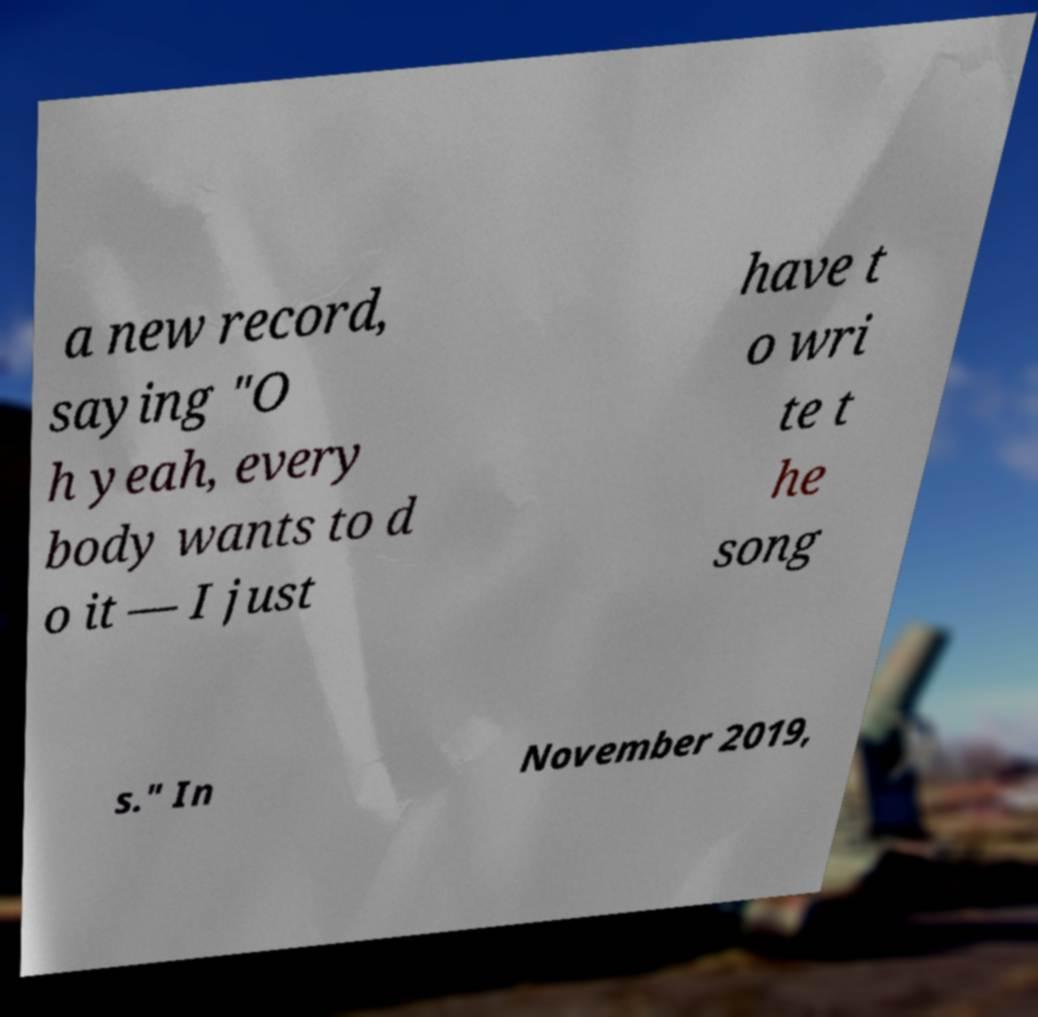What messages or text are displayed in this image? I need them in a readable, typed format. a new record, saying "O h yeah, every body wants to d o it — I just have t o wri te t he song s." In November 2019, 